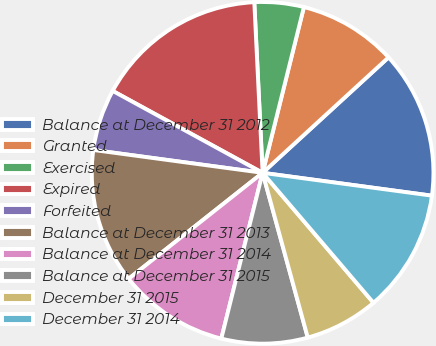Convert chart. <chart><loc_0><loc_0><loc_500><loc_500><pie_chart><fcel>Balance at December 31 2012<fcel>Granted<fcel>Exercised<fcel>Expired<fcel>Forfeited<fcel>Balance at December 31 2013<fcel>Balance at December 31 2014<fcel>Balance at December 31 2015<fcel>December 31 2015<fcel>December 31 2014<nl><fcel>13.94%<fcel>9.3%<fcel>4.66%<fcel>16.26%<fcel>5.82%<fcel>12.78%<fcel>10.46%<fcel>8.14%<fcel>6.98%<fcel>11.62%<nl></chart> 